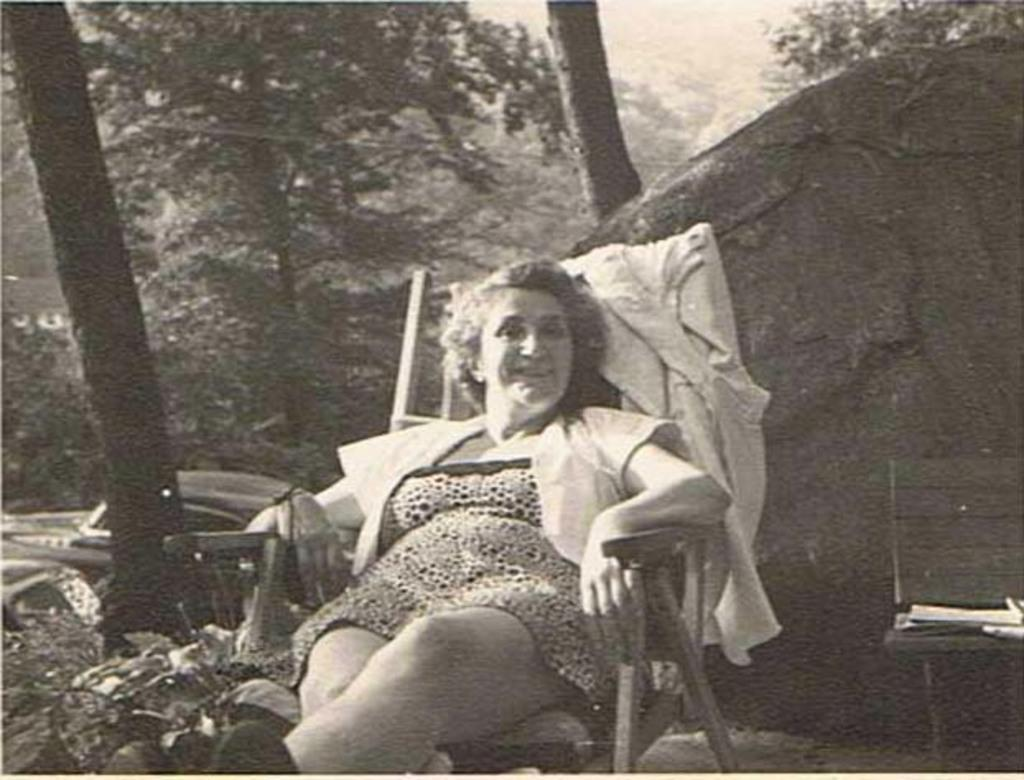What is the person in the image doing? The person is sitting on a chair in the image. What can be seen in the background of the image? Trees and the sky are visible in the image. What other object can be seen in the image? There is a rock visible in the image. What type of sail is attached to the rock in the image? There is no sail present in the image; it only features a person sitting on a chair, trees, a rock, and the sky. 